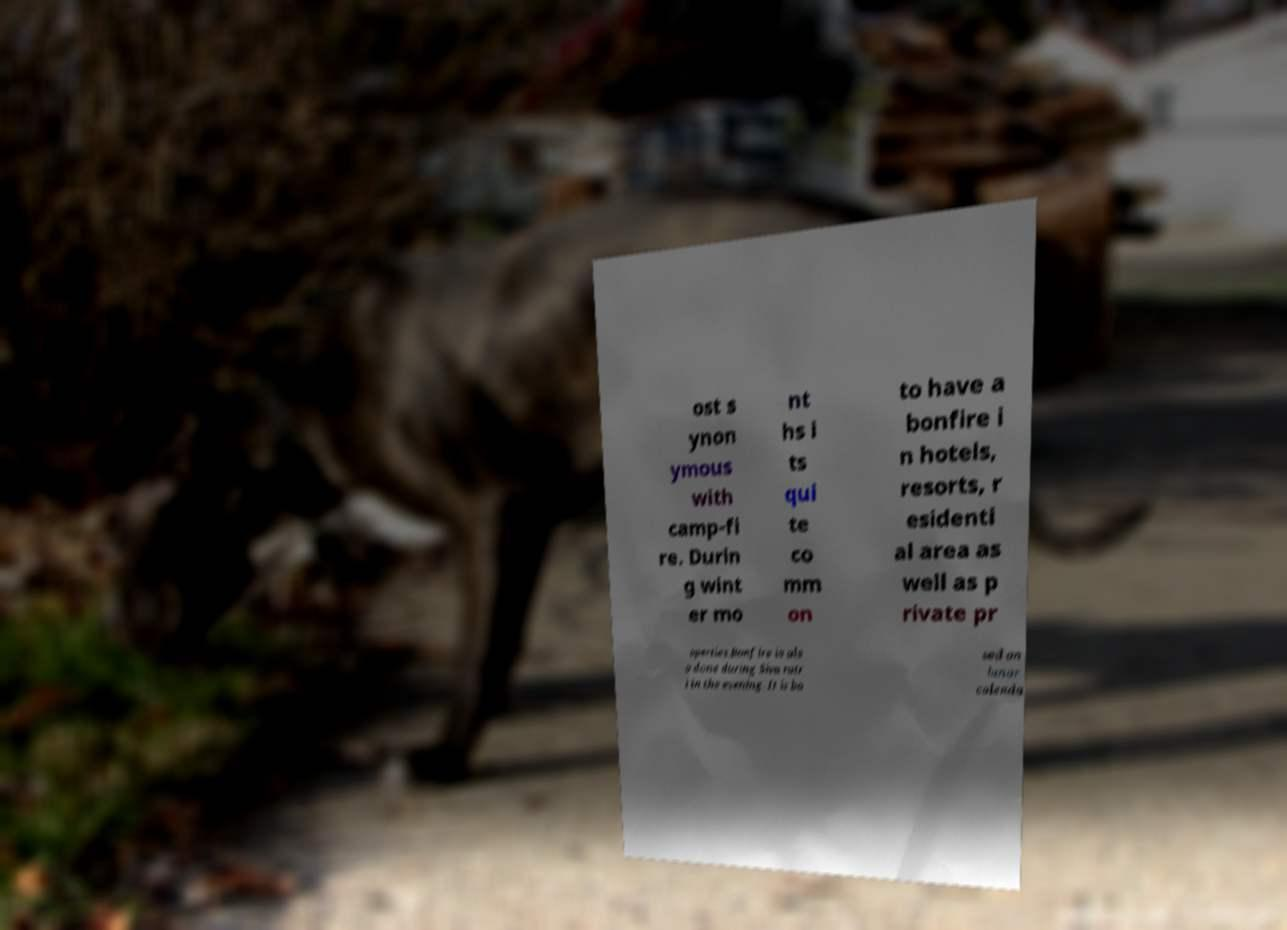Could you extract and type out the text from this image? ost s ynon ymous with camp-fi re. Durin g wint er mo nt hs i ts qui te co mm on to have a bonfire i n hotels, resorts, r esidenti al area as well as p rivate pr operties.Bonfire is als o done during Siva ratr i in the evening. It is ba sed on lunar calenda 